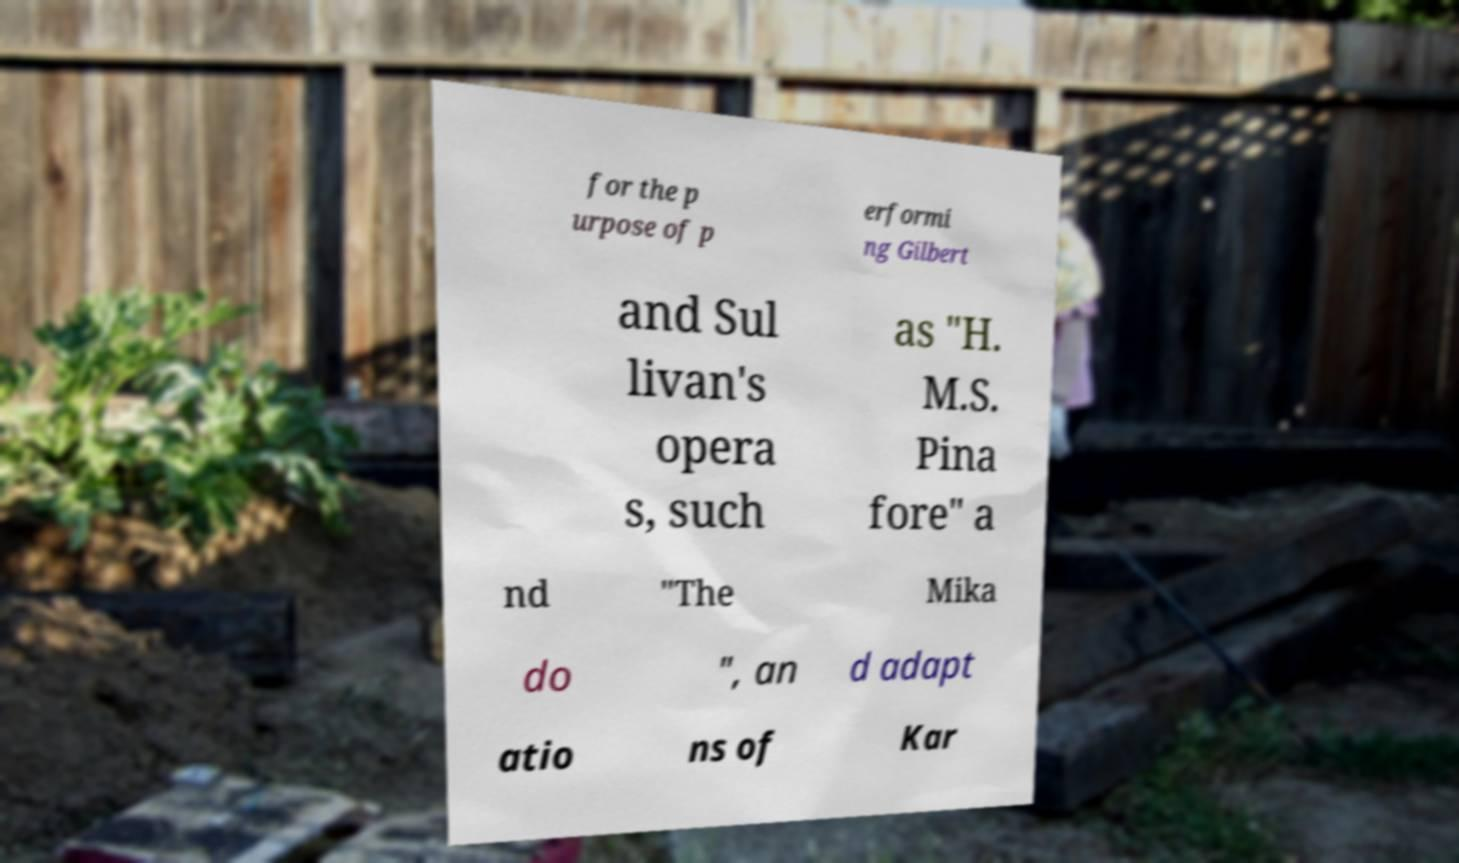What messages or text are displayed in this image? I need them in a readable, typed format. for the p urpose of p erformi ng Gilbert and Sul livan's opera s, such as "H. M.S. Pina fore" a nd "The Mika do ", an d adapt atio ns of Kar 